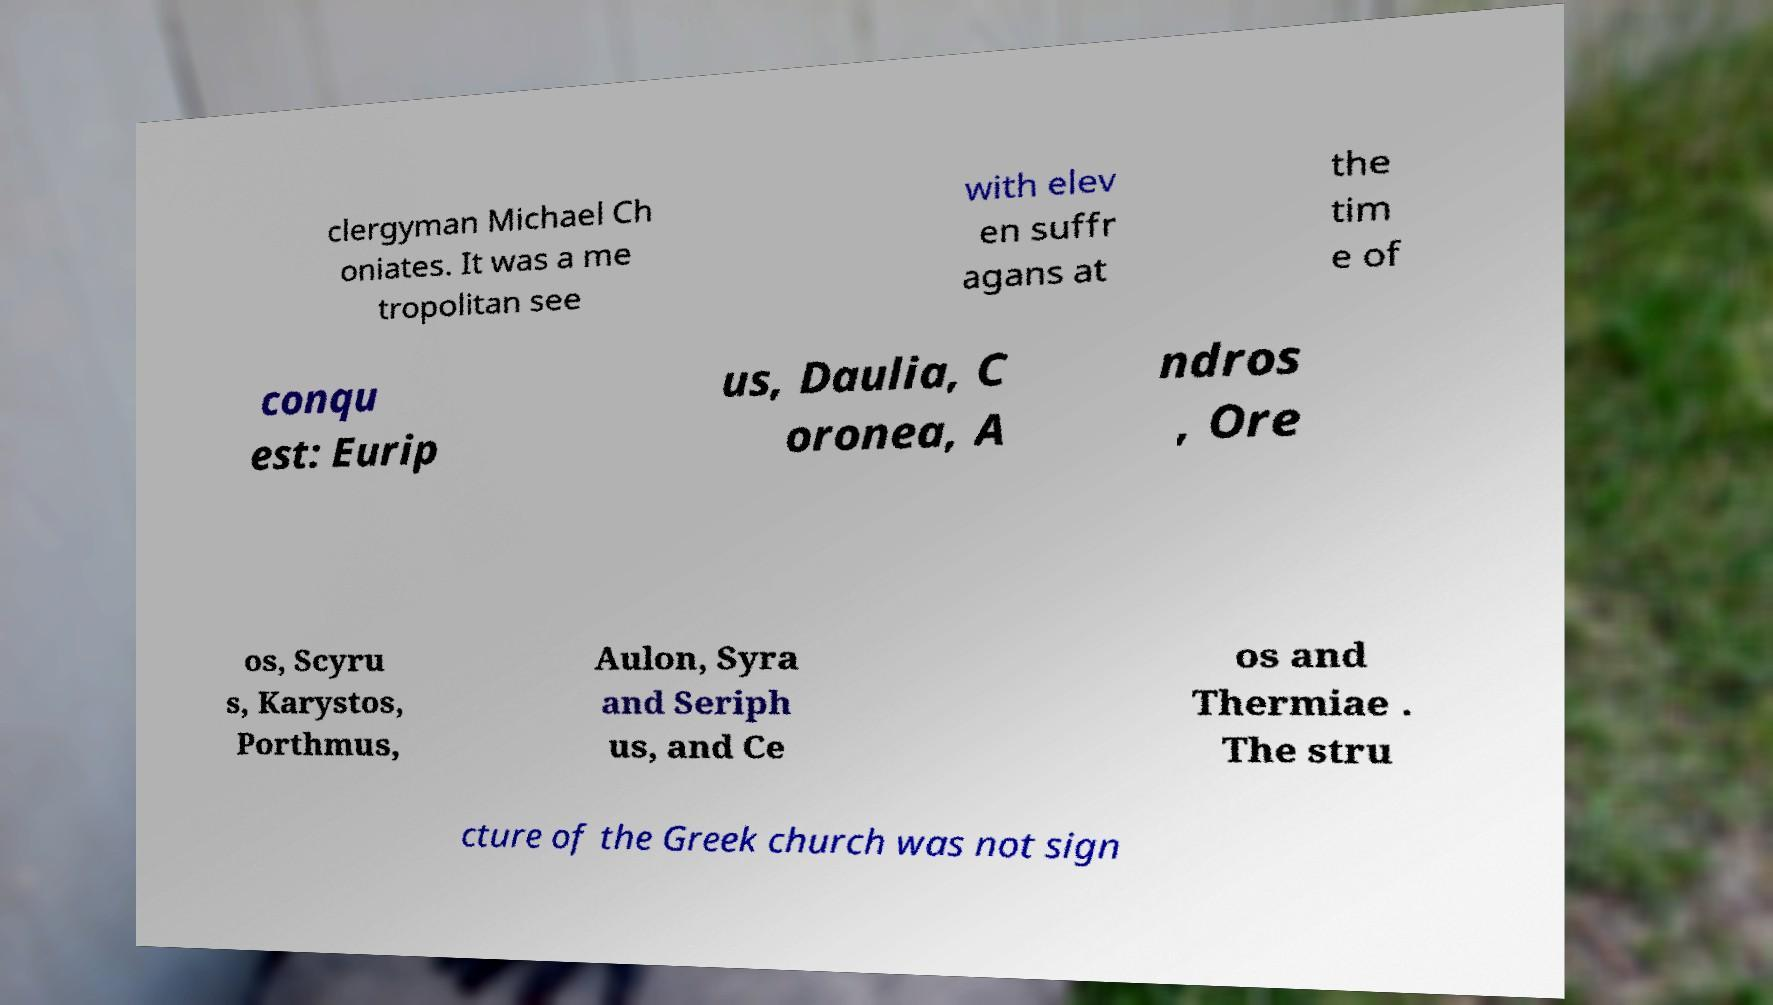What messages or text are displayed in this image? I need them in a readable, typed format. clergyman Michael Ch oniates. It was a me tropolitan see with elev en suffr agans at the tim e of conqu est: Eurip us, Daulia, C oronea, A ndros , Ore os, Scyru s, Karystos, Porthmus, Aulon, Syra and Seriph us, and Ce os and Thermiae . The stru cture of the Greek church was not sign 